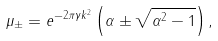Convert formula to latex. <formula><loc_0><loc_0><loc_500><loc_500>\mu _ { \pm } = e ^ { - 2 \pi \gamma k ^ { 2 } } \left ( \alpha \pm \sqrt { \alpha ^ { 2 } - 1 } \right ) ,</formula> 